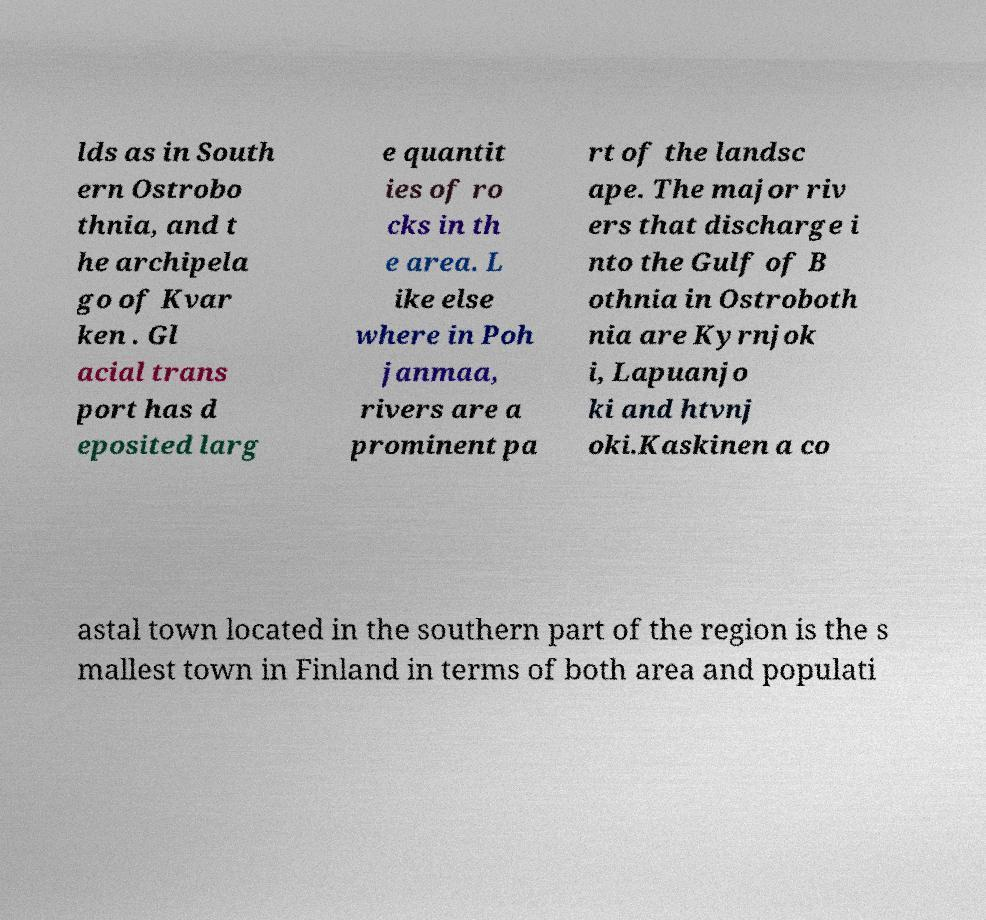For documentation purposes, I need the text within this image transcribed. Could you provide that? lds as in South ern Ostrobo thnia, and t he archipela go of Kvar ken . Gl acial trans port has d eposited larg e quantit ies of ro cks in th e area. L ike else where in Poh janmaa, rivers are a prominent pa rt of the landsc ape. The major riv ers that discharge i nto the Gulf of B othnia in Ostroboth nia are Kyrnjok i, Lapuanjo ki and htvnj oki.Kaskinen a co astal town located in the southern part of the region is the s mallest town in Finland in terms of both area and populati 